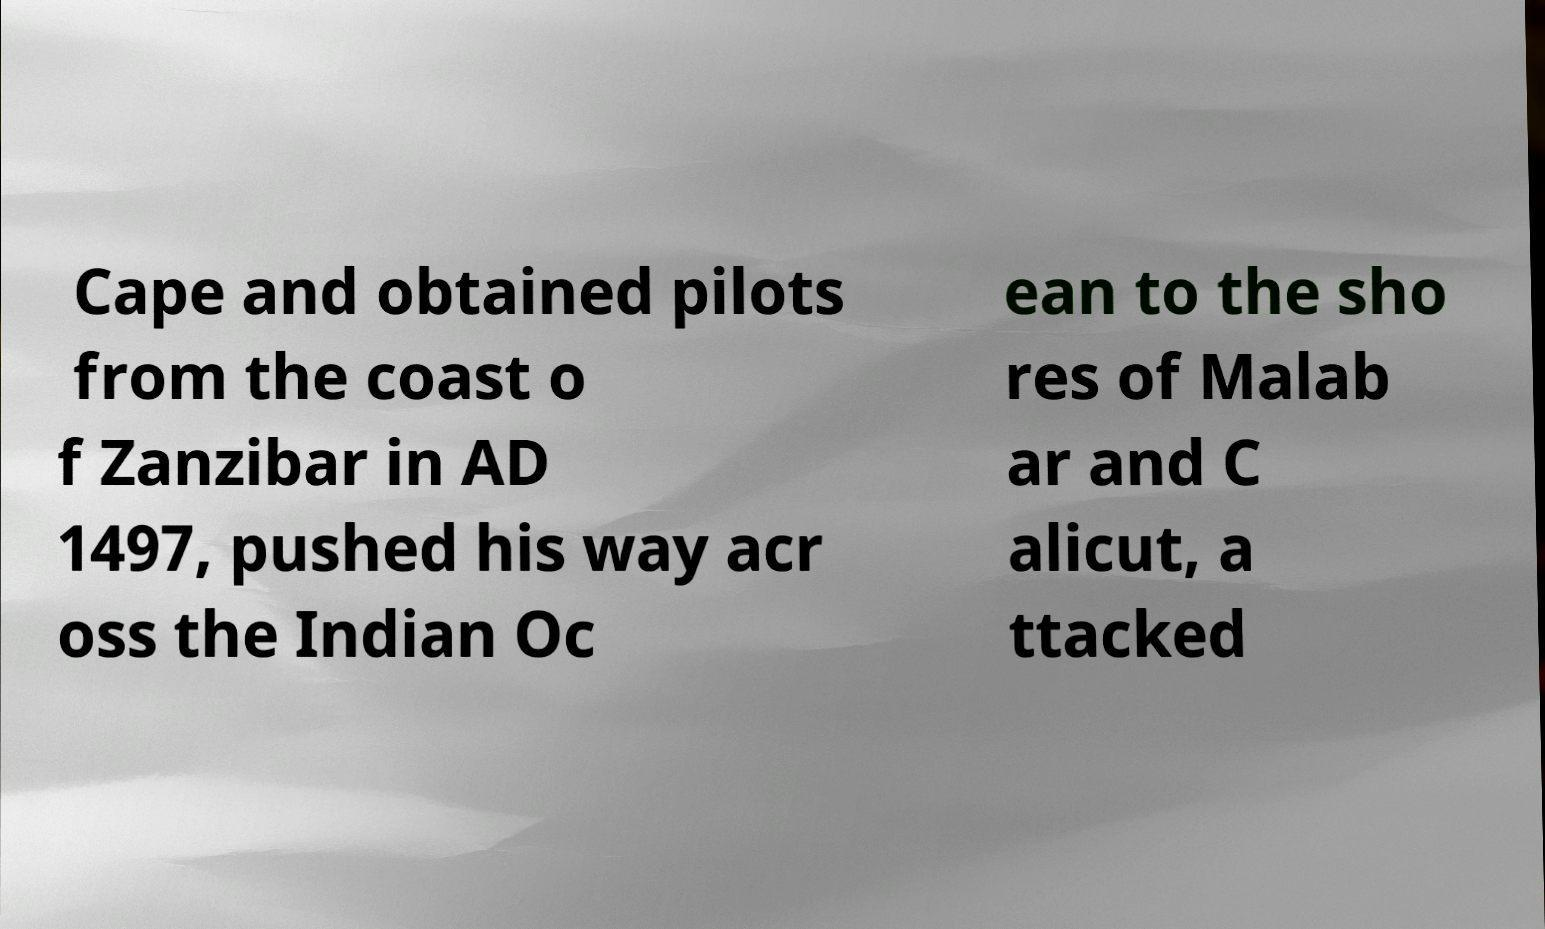Please identify and transcribe the text found in this image. Cape and obtained pilots from the coast o f Zanzibar in AD 1497, pushed his way acr oss the Indian Oc ean to the sho res of Malab ar and C alicut, a ttacked 